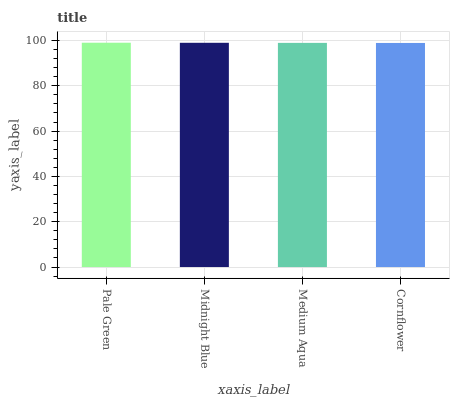Is Cornflower the minimum?
Answer yes or no. Yes. Is Pale Green the maximum?
Answer yes or no. Yes. Is Midnight Blue the minimum?
Answer yes or no. No. Is Midnight Blue the maximum?
Answer yes or no. No. Is Pale Green greater than Midnight Blue?
Answer yes or no. Yes. Is Midnight Blue less than Pale Green?
Answer yes or no. Yes. Is Midnight Blue greater than Pale Green?
Answer yes or no. No. Is Pale Green less than Midnight Blue?
Answer yes or no. No. Is Midnight Blue the high median?
Answer yes or no. Yes. Is Medium Aqua the low median?
Answer yes or no. Yes. Is Medium Aqua the high median?
Answer yes or no. No. Is Pale Green the low median?
Answer yes or no. No. 